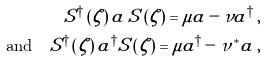<formula> <loc_0><loc_0><loc_500><loc_500>S ^ { \dagger } \left ( \zeta \right ) a \, S \left ( \zeta \right ) = \mu a - \nu a ^ { \dagger } \, , \\ \quad \text {and} \quad S ^ { \dagger } \left ( \zeta \right ) a ^ { \dagger } S \left ( \zeta \right ) = \mu a ^ { \dagger } - \nu ^ { * } a \, ,</formula> 